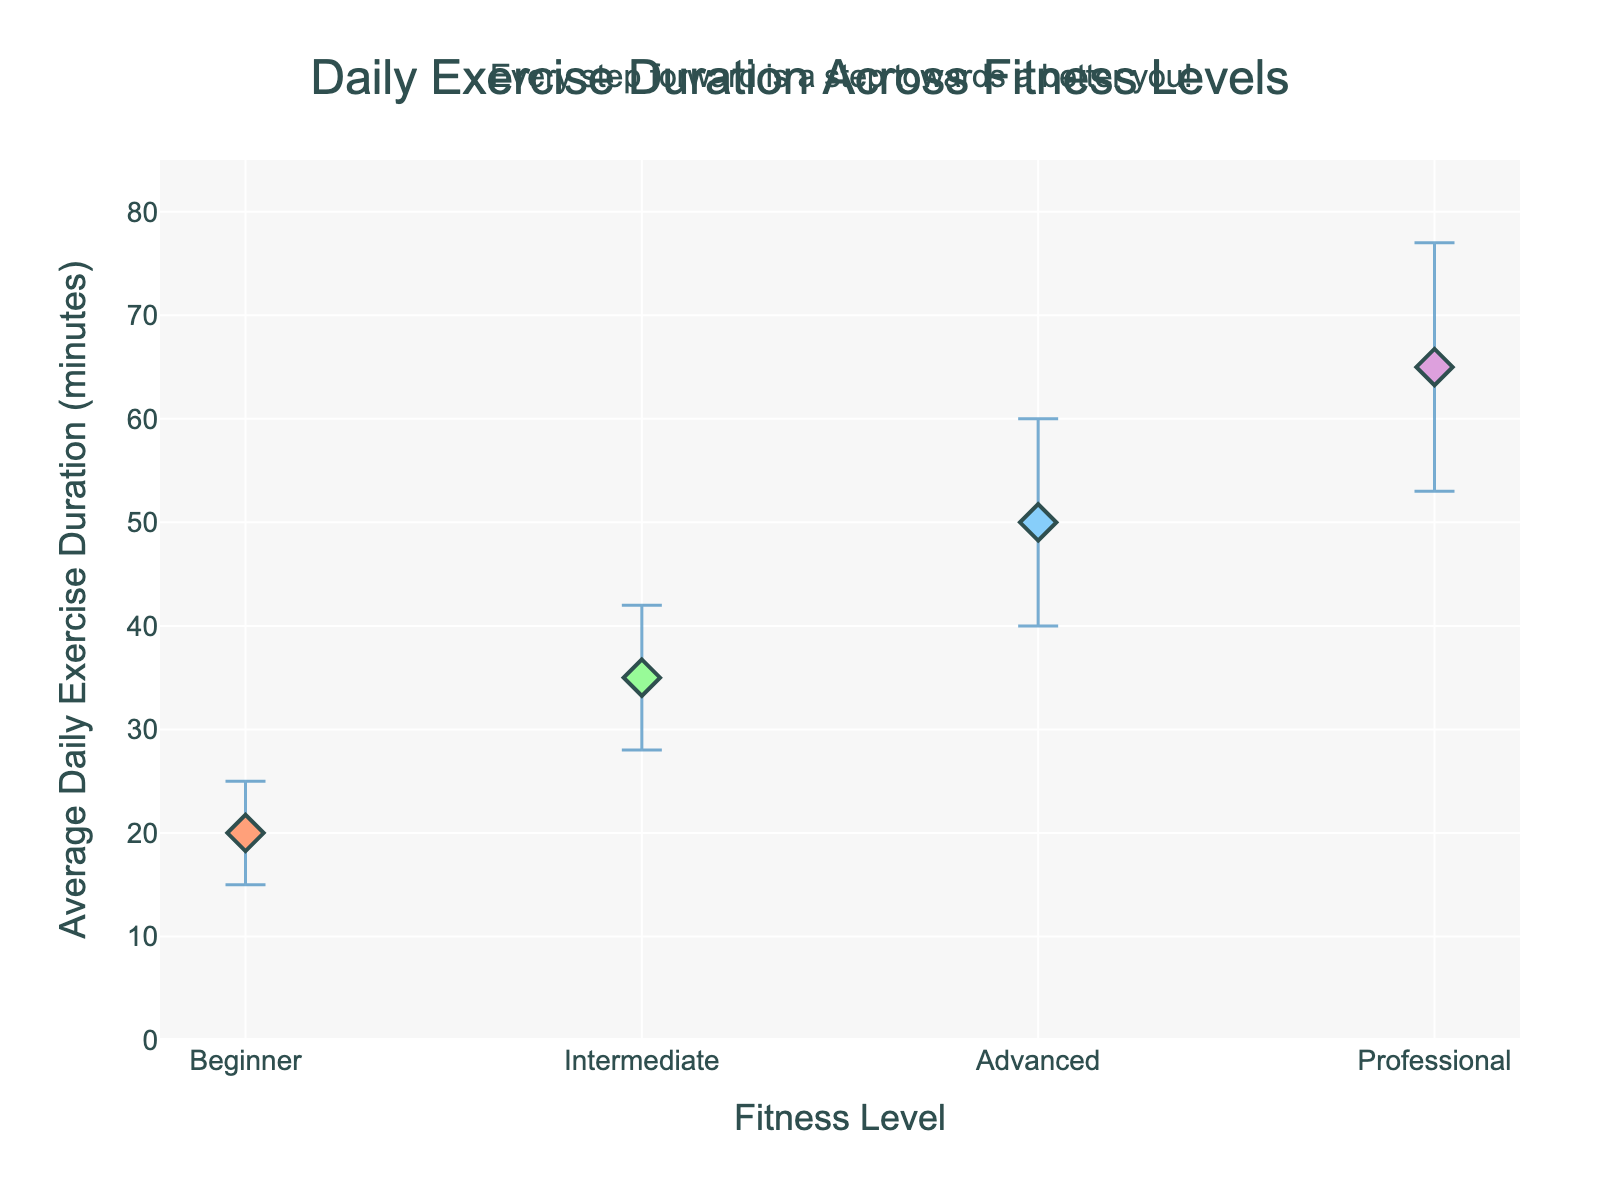What is the title of the plot? The title is clearly displayed at the top of the figure as a descriptive statement.
Answer: Daily Exercise Duration Across Fitness Levels How many fitness levels are represented in the plot? The x-axis labels list out each fitness level represented in the data.
Answer: 4 What is the average daily exercise duration for the Professional fitness level? The dot corresponding to the Professional fitness level on the x-axis shows the average daily exercise duration on the y-axis.
Answer: 65 minutes Which fitness level has the highest standard deviation in exercise duration? By comparing the length of the error bars for each fitness level, the Professional level's error bar is the longest.
Answer: Professional What is the average daily exercise duration difference between Intermediate and Beginner levels? Subtract the Beginner's average daily exercise duration from the Intermediate's. That's 35 - 20 = 15 minutes.
Answer: 15 minutes What is the range of average exercise durations shown in the plot? The minimum value corresponds to the Beginner level (20 minutes) and the maximum value to the Professional level (65 minutes), giving a range of 65 - 20 = 45 minutes.
Answer: 45 minutes Between which two adjacent fitness levels is the increase in average daily exercise duration the smallest? Calculate the differences between each pair of adjacent fitness levels: Beginner to Intermediate (15), Intermediate to Advanced (15), and Advanced to Professional (15). The increases are the same for each pair.
Answer: Beginner to Intermediate, Intermediate to Advanced, Advanced to Professional (all the same) How does the average daily exercise duration for the Advanced group compare to that of the Intermediate group? The average daily exercise duration for the Advanced group (50 minutes) is higher than for the Intermediate group (35 minutes).
Answer: Advanced > Intermediate What is the message of the motivational quote included in the plot? The annotation above the title provides a motivational message aimed at encouraging viewers.
Answer: Every step forward is a step towards a better you! Which fitness level has the most precise (least variable) daily exercise duration? The fitness level with the shortest error bar indicates the least variation, visible in the Beginner level.
Answer: Beginner 